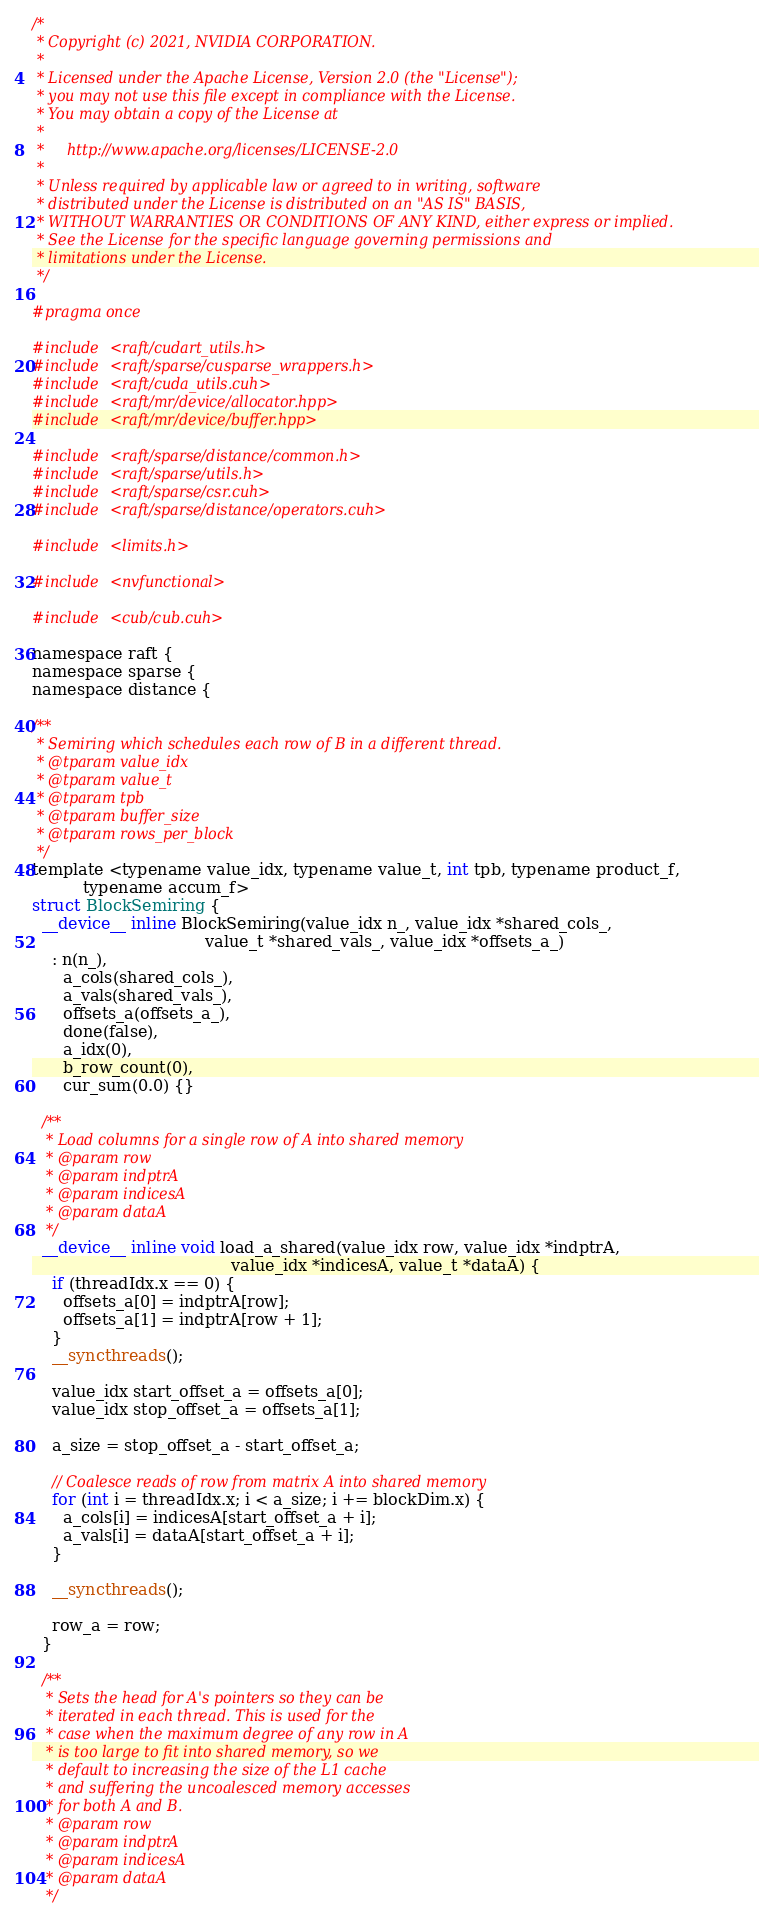Convert code to text. <code><loc_0><loc_0><loc_500><loc_500><_Cuda_>/*
 * Copyright (c) 2021, NVIDIA CORPORATION.
 *
 * Licensed under the Apache License, Version 2.0 (the "License");
 * you may not use this file except in compliance with the License.
 * You may obtain a copy of the License at
 *
 *     http://www.apache.org/licenses/LICENSE-2.0
 *
 * Unless required by applicable law or agreed to in writing, software
 * distributed under the License is distributed on an "AS IS" BASIS,
 * WITHOUT WARRANTIES OR CONDITIONS OF ANY KIND, either express or implied.
 * See the License for the specific language governing permissions and
 * limitations under the License.
 */

#pragma once

#include <raft/cudart_utils.h>
#include <raft/sparse/cusparse_wrappers.h>
#include <raft/cuda_utils.cuh>
#include <raft/mr/device/allocator.hpp>
#include <raft/mr/device/buffer.hpp>

#include <raft/sparse/distance/common.h>
#include <raft/sparse/utils.h>
#include <raft/sparse/csr.cuh>
#include <raft/sparse/distance/operators.cuh>

#include <limits.h>

#include <nvfunctional>

#include <cub/cub.cuh>

namespace raft {
namespace sparse {
namespace distance {

/**
 * Semiring which schedules each row of B in a different thread.
 * @tparam value_idx
 * @tparam value_t
 * @tparam tpb
 * @tparam buffer_size
 * @tparam rows_per_block
 */
template <typename value_idx, typename value_t, int tpb, typename product_f,
          typename accum_f>
struct BlockSemiring {
  __device__ inline BlockSemiring(value_idx n_, value_idx *shared_cols_,
                                  value_t *shared_vals_, value_idx *offsets_a_)
    : n(n_),
      a_cols(shared_cols_),
      a_vals(shared_vals_),
      offsets_a(offsets_a_),
      done(false),
      a_idx(0),
      b_row_count(0),
      cur_sum(0.0) {}

  /**
   * Load columns for a single row of A into shared memory
   * @param row
   * @param indptrA
   * @param indicesA
   * @param dataA
   */
  __device__ inline void load_a_shared(value_idx row, value_idx *indptrA,
                                       value_idx *indicesA, value_t *dataA) {
    if (threadIdx.x == 0) {
      offsets_a[0] = indptrA[row];
      offsets_a[1] = indptrA[row + 1];
    }
    __syncthreads();

    value_idx start_offset_a = offsets_a[0];
    value_idx stop_offset_a = offsets_a[1];

    a_size = stop_offset_a - start_offset_a;

    // Coalesce reads of row from matrix A into shared memory
    for (int i = threadIdx.x; i < a_size; i += blockDim.x) {
      a_cols[i] = indicesA[start_offset_a + i];
      a_vals[i] = dataA[start_offset_a + i];
    }

    __syncthreads();

    row_a = row;
  }

  /**
   * Sets the head for A's pointers so they can be
   * iterated in each thread. This is used for the
   * case when the maximum degree of any row in A
   * is too large to fit into shared memory, so we
   * default to increasing the size of the L1 cache
   * and suffering the uncoalesced memory accesses
   * for both A and B.
   * @param row
   * @param indptrA
   * @param indicesA
   * @param dataA
   */</code> 